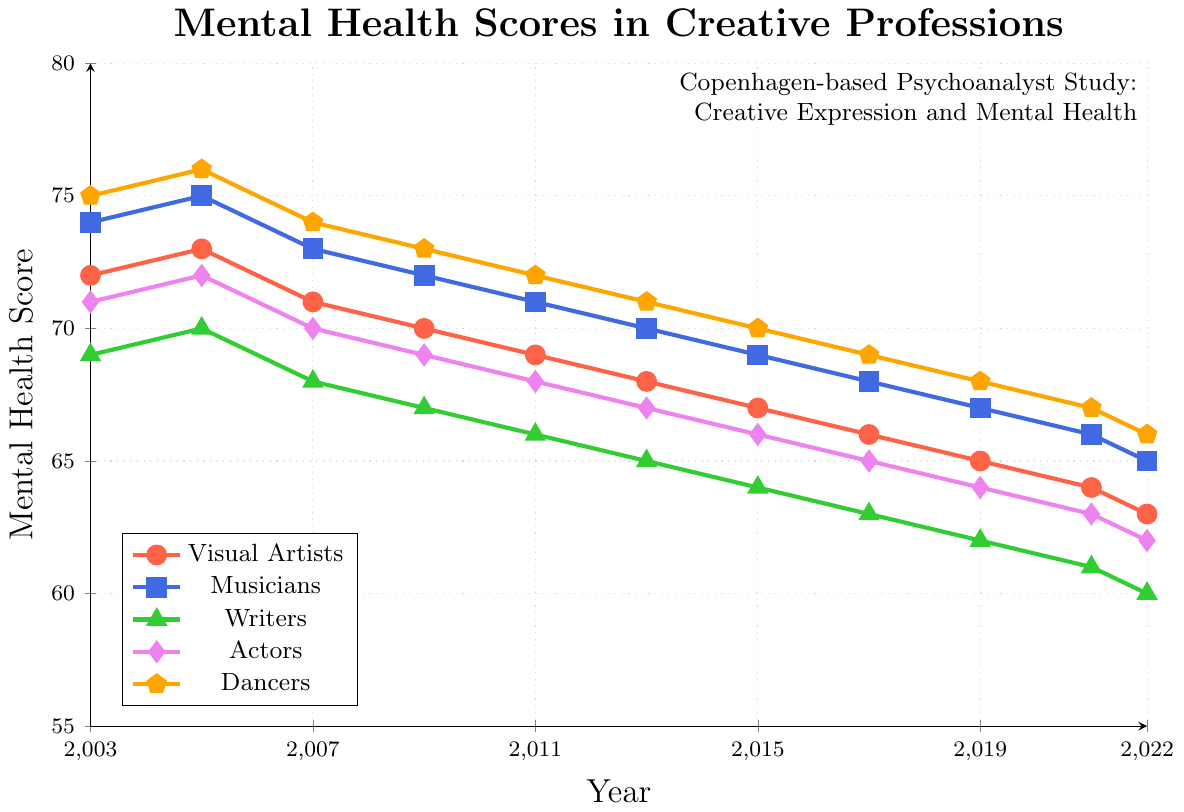What's the general trend in mental health scores for Visual Artists from 2003 to 2022? To determine the trend, examine the data points for Visual Artists from 2003 (72) to 2022 (63). The scores show a consistent decline over the years.
Answer: A declining trend In which year did Musicians have the highest mental health score, and what was the score? Observe the data points for Musicians. The highest score is 75, which occurred in 2005.
Answer: 2005 and 75 How do the mental health scores of Writers in 2022 compare to those of Dancers in the same year? Check the scores for both Writers (60) and Dancers (66) in 2022. Writers have lower scores than Dancers.
Answer: Writers: 60, Dancers: 66 What is the average mental health score for Actors in the dataset? Sum the scores for Actors over all the years and divide by the number of data points (71+72+70+69+68+67+66+65+64+63+62)/11. The calculation is (707/11).
Answer: 64.27 Which profession experienced the steepest decline in mental health scores between 2003 and 2022? Calculate the decline for each profession by subtracting the 2022 score from the 2003 score: Visual Artists (72-63=9), Musicians (74-65=9), Writers (69-60=9), Actors (71-62=9), Dancers (75-66=9). All professions experienced the same decline.
Answer: All professions (9) Between which consecutive years did Visual Artists experience the greatest drop in mental health scores? By examining the data points for Visual Artists year-by-year, the steepest drop occurred between 2005 (73) and 2007 (71), which is a decline of 2 points.
Answer: Between 2005 and 2007 How did the mental health scores for Dancers change from 2003 to 2022? The scores for Dancers in 2003 were 75 and in 2022 were 66. The scores declined by 9 points.
Answer: Declined by 9 points What is the median mental health score for Writers from 2003 to 2022? List the scores for Writers from 2003 to 2022 (69, 70, 68, 67, 66, 65, 64, 63, 62, 61, 60), and find the middle value, which is 65.
Answer: 65 Compare the mental health scores of Musicians and Dancers in 2015. Which group had higher scores? In 2015, Musicians had a score of 69 and Dancers had a score of 70. Dancers had higher scores.
Answer: Dancers (70) By how much did the mental health score for Writers decrease between 2009 and 2019? Subtract the 2019 score (62) from the 2009 score (67) for Writers. The decrease is 5 points.
Answer: Decreased by 5 points 